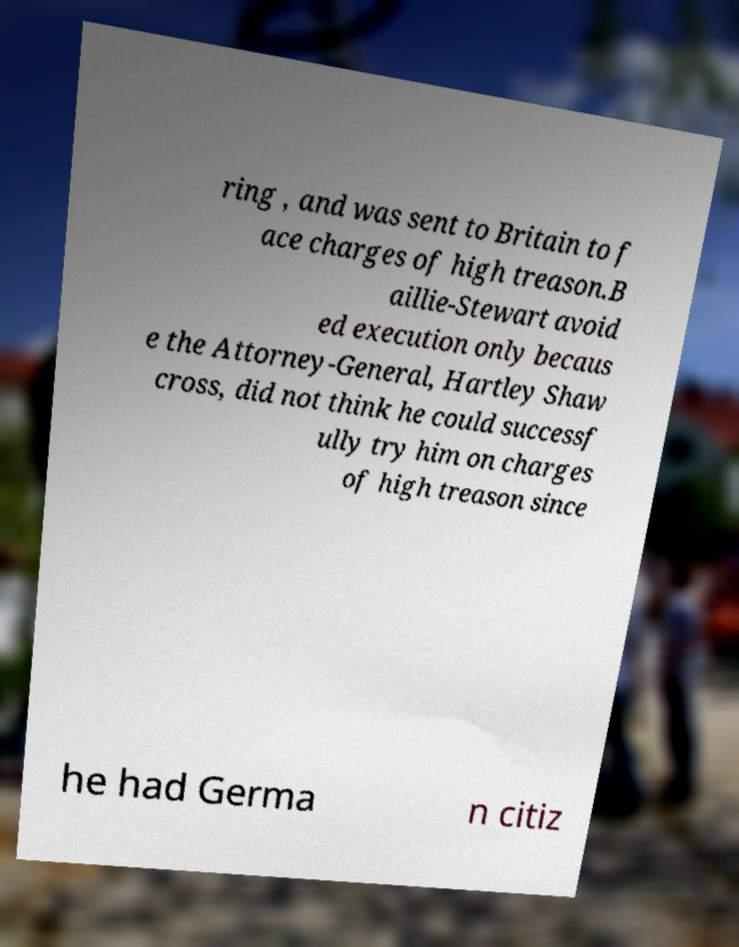What messages or text are displayed in this image? I need them in a readable, typed format. ring , and was sent to Britain to f ace charges of high treason.B aillie-Stewart avoid ed execution only becaus e the Attorney-General, Hartley Shaw cross, did not think he could successf ully try him on charges of high treason since he had Germa n citiz 